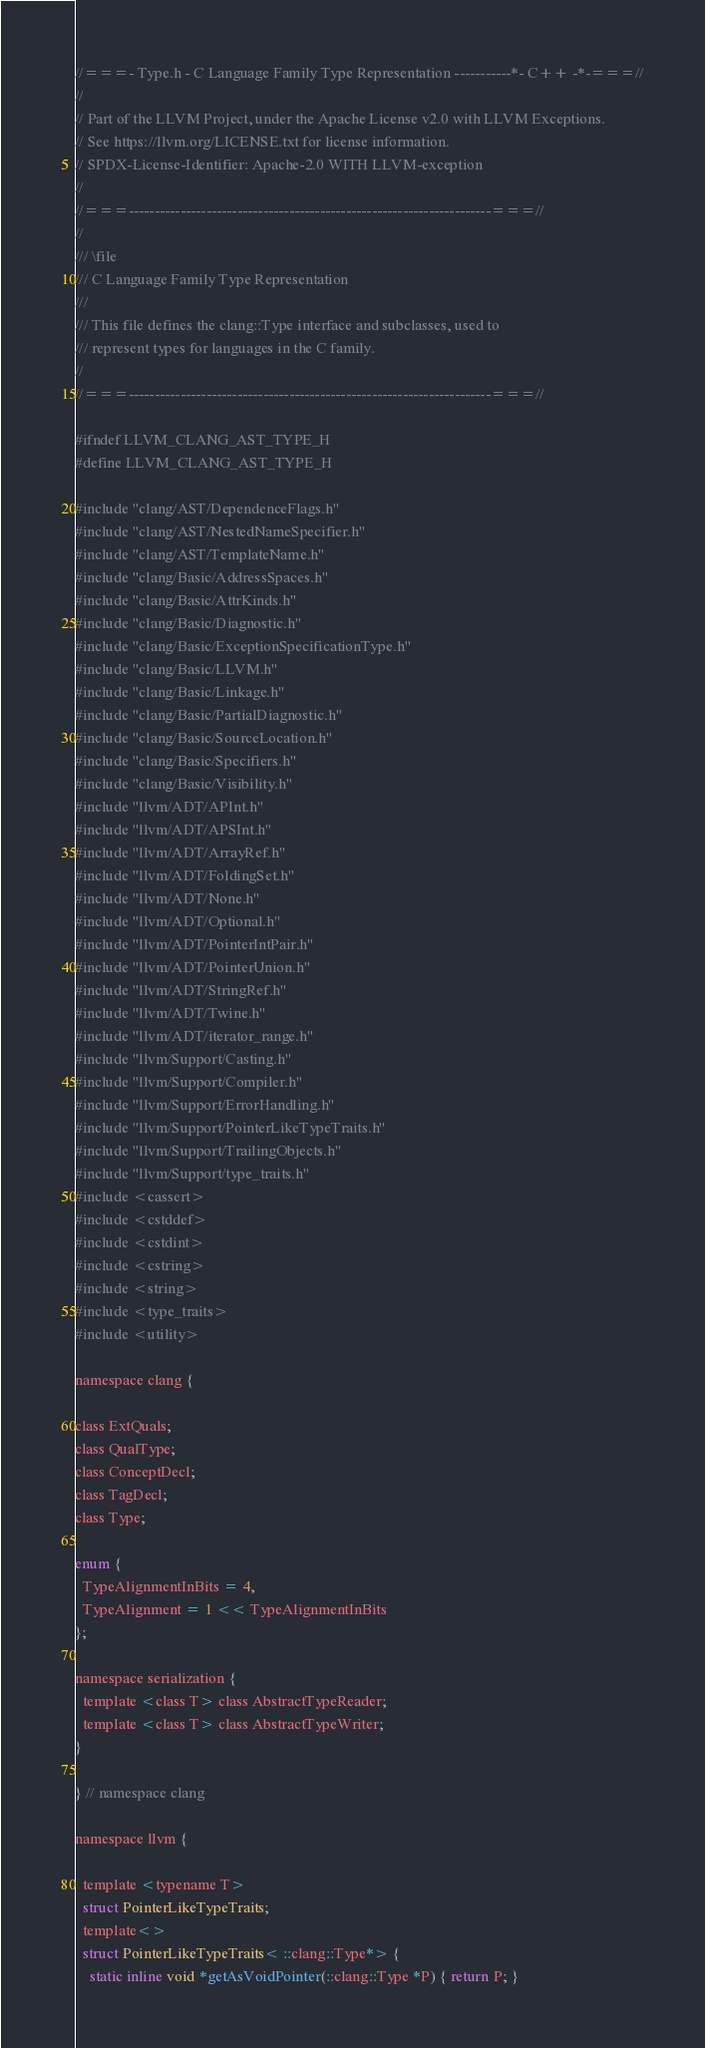Convert code to text. <code><loc_0><loc_0><loc_500><loc_500><_C_>//===- Type.h - C Language Family Type Representation -----------*- C++ -*-===//
//
// Part of the LLVM Project, under the Apache License v2.0 with LLVM Exceptions.
// See https://llvm.org/LICENSE.txt for license information.
// SPDX-License-Identifier: Apache-2.0 WITH LLVM-exception
//
//===----------------------------------------------------------------------===//
//
/// \file
/// C Language Family Type Representation
///
/// This file defines the clang::Type interface and subclasses, used to
/// represent types for languages in the C family.
//
//===----------------------------------------------------------------------===//

#ifndef LLVM_CLANG_AST_TYPE_H
#define LLVM_CLANG_AST_TYPE_H

#include "clang/AST/DependenceFlags.h"
#include "clang/AST/NestedNameSpecifier.h"
#include "clang/AST/TemplateName.h"
#include "clang/Basic/AddressSpaces.h"
#include "clang/Basic/AttrKinds.h"
#include "clang/Basic/Diagnostic.h"
#include "clang/Basic/ExceptionSpecificationType.h"
#include "clang/Basic/LLVM.h"
#include "clang/Basic/Linkage.h"
#include "clang/Basic/PartialDiagnostic.h"
#include "clang/Basic/SourceLocation.h"
#include "clang/Basic/Specifiers.h"
#include "clang/Basic/Visibility.h"
#include "llvm/ADT/APInt.h"
#include "llvm/ADT/APSInt.h"
#include "llvm/ADT/ArrayRef.h"
#include "llvm/ADT/FoldingSet.h"
#include "llvm/ADT/None.h"
#include "llvm/ADT/Optional.h"
#include "llvm/ADT/PointerIntPair.h"
#include "llvm/ADT/PointerUnion.h"
#include "llvm/ADT/StringRef.h"
#include "llvm/ADT/Twine.h"
#include "llvm/ADT/iterator_range.h"
#include "llvm/Support/Casting.h"
#include "llvm/Support/Compiler.h"
#include "llvm/Support/ErrorHandling.h"
#include "llvm/Support/PointerLikeTypeTraits.h"
#include "llvm/Support/TrailingObjects.h"
#include "llvm/Support/type_traits.h"
#include <cassert>
#include <cstddef>
#include <cstdint>
#include <cstring>
#include <string>
#include <type_traits>
#include <utility>

namespace clang {

class ExtQuals;
class QualType;
class ConceptDecl;
class TagDecl;
class Type;

enum {
  TypeAlignmentInBits = 4,
  TypeAlignment = 1 << TypeAlignmentInBits
};

namespace serialization {
  template <class T> class AbstractTypeReader;
  template <class T> class AbstractTypeWriter;
}

} // namespace clang

namespace llvm {

  template <typename T>
  struct PointerLikeTypeTraits;
  template<>
  struct PointerLikeTypeTraits< ::clang::Type*> {
    static inline void *getAsVoidPointer(::clang::Type *P) { return P; }
</code> 